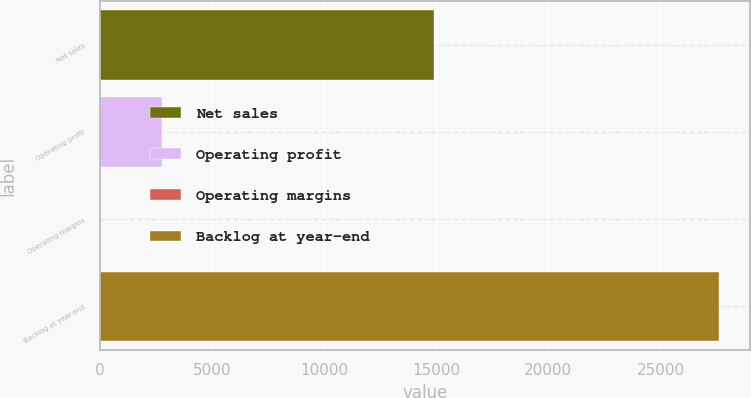Convert chart to OTSL. <chart><loc_0><loc_0><loc_500><loc_500><bar_chart><fcel>Net sales<fcel>Operating profit<fcel>Operating margins<fcel>Backlog at year-end<nl><fcel>14920<fcel>2769.99<fcel>11.1<fcel>27600<nl></chart> 